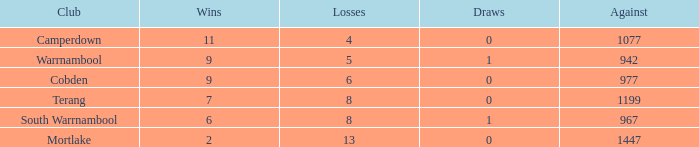What is the tie when the losses surpassed 8 and were under 2 wins? None. 